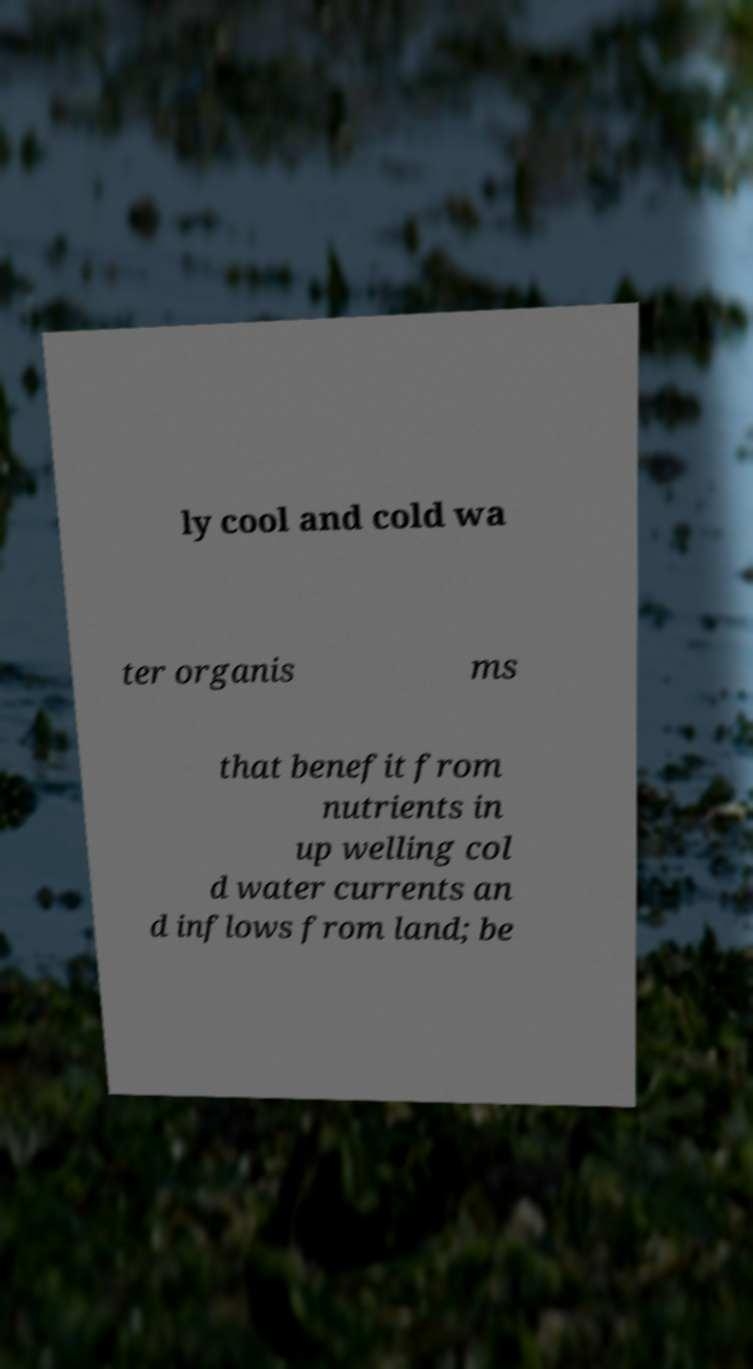Could you extract and type out the text from this image? ly cool and cold wa ter organis ms that benefit from nutrients in up welling col d water currents an d inflows from land; be 